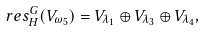Convert formula to latex. <formula><loc_0><loc_0><loc_500><loc_500>\ r e s ^ { G } _ { H } ( V _ { \omega _ { 5 } } ) = V _ { \lambda _ { 1 } } \oplus V _ { \lambda _ { 3 } } \oplus V _ { \lambda _ { 4 } } ,</formula> 